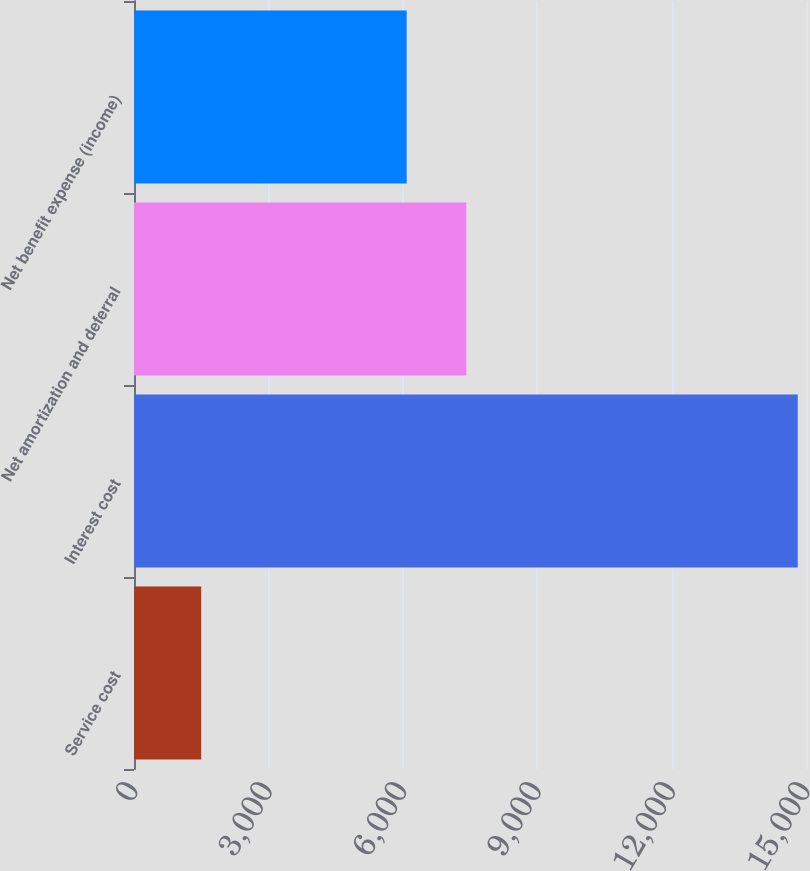<chart> <loc_0><loc_0><loc_500><loc_500><bar_chart><fcel>Service cost<fcel>Interest cost<fcel>Net amortization and deferral<fcel>Net benefit expense (income)<nl><fcel>1500<fcel>14816<fcel>7418.6<fcel>6087<nl></chart> 